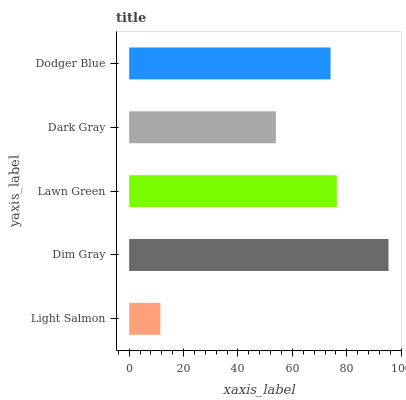Is Light Salmon the minimum?
Answer yes or no. Yes. Is Dim Gray the maximum?
Answer yes or no. Yes. Is Lawn Green the minimum?
Answer yes or no. No. Is Lawn Green the maximum?
Answer yes or no. No. Is Dim Gray greater than Lawn Green?
Answer yes or no. Yes. Is Lawn Green less than Dim Gray?
Answer yes or no. Yes. Is Lawn Green greater than Dim Gray?
Answer yes or no. No. Is Dim Gray less than Lawn Green?
Answer yes or no. No. Is Dodger Blue the high median?
Answer yes or no. Yes. Is Dodger Blue the low median?
Answer yes or no. Yes. Is Light Salmon the high median?
Answer yes or no. No. Is Light Salmon the low median?
Answer yes or no. No. 